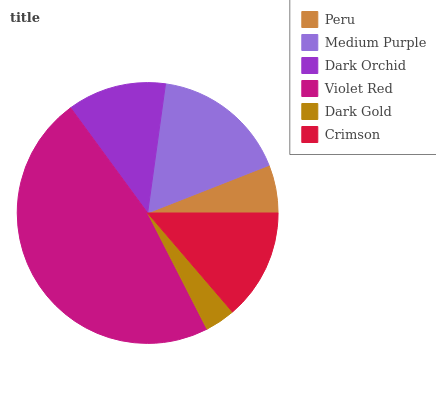Is Dark Gold the minimum?
Answer yes or no. Yes. Is Violet Red the maximum?
Answer yes or no. Yes. Is Medium Purple the minimum?
Answer yes or no. No. Is Medium Purple the maximum?
Answer yes or no. No. Is Medium Purple greater than Peru?
Answer yes or no. Yes. Is Peru less than Medium Purple?
Answer yes or no. Yes. Is Peru greater than Medium Purple?
Answer yes or no. No. Is Medium Purple less than Peru?
Answer yes or no. No. Is Crimson the high median?
Answer yes or no. Yes. Is Dark Orchid the low median?
Answer yes or no. Yes. Is Dark Orchid the high median?
Answer yes or no. No. Is Peru the low median?
Answer yes or no. No. 